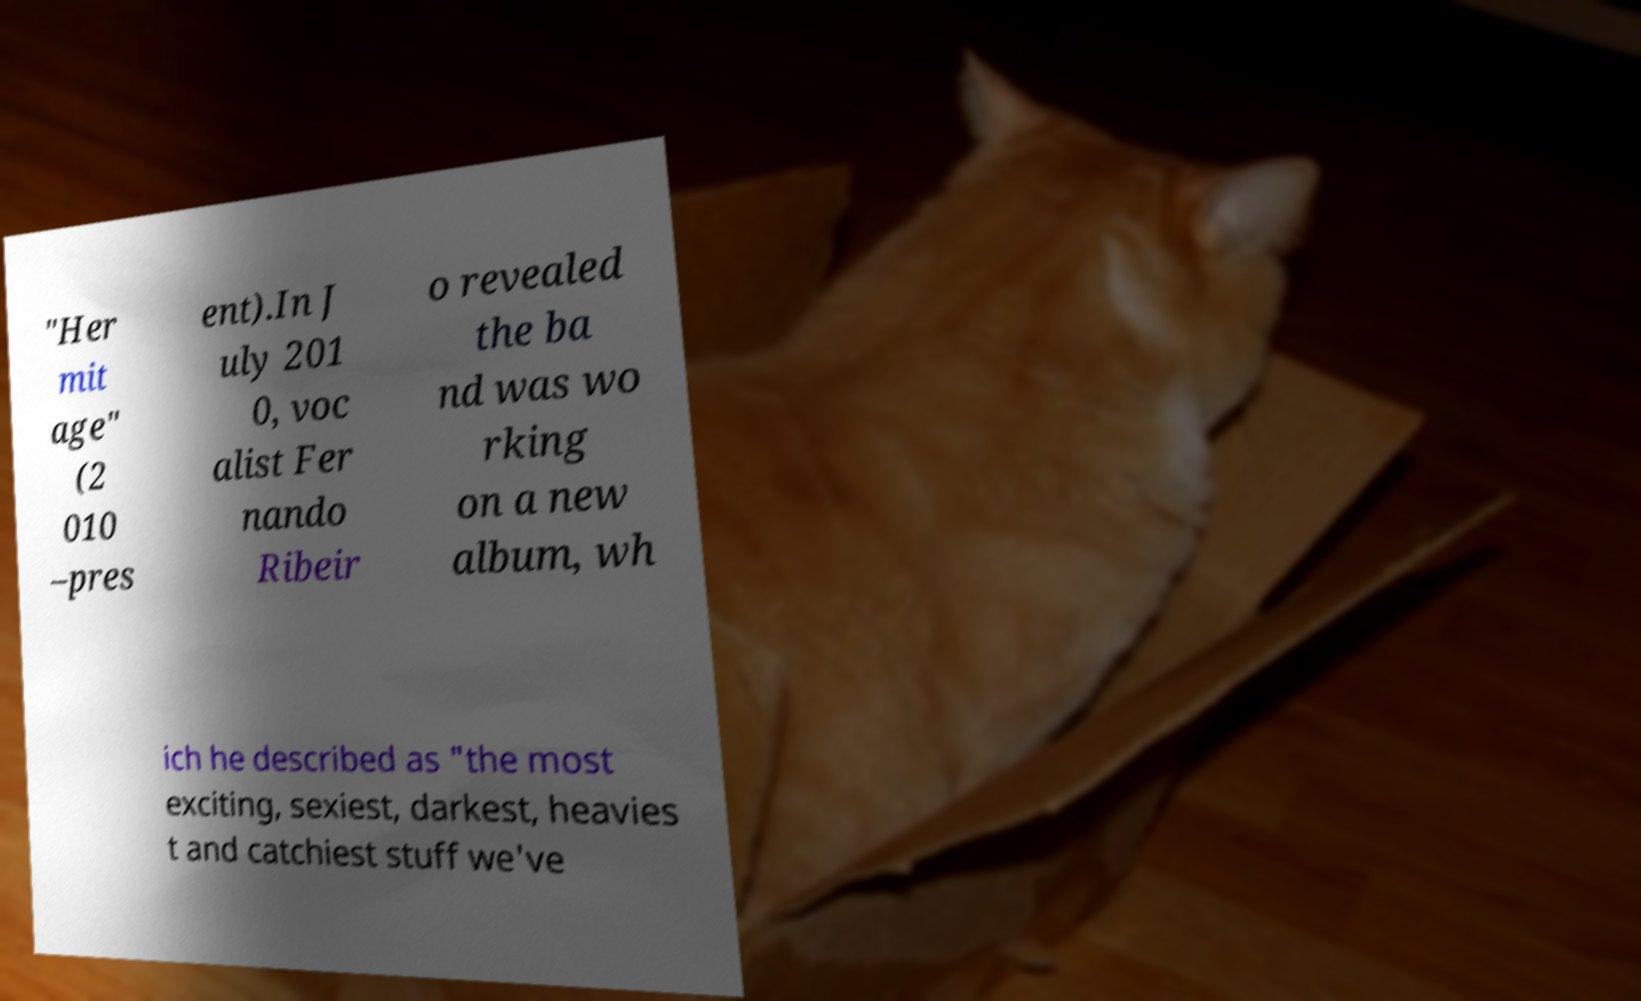Could you assist in decoding the text presented in this image and type it out clearly? "Her mit age" (2 010 –pres ent).In J uly 201 0, voc alist Fer nando Ribeir o revealed the ba nd was wo rking on a new album, wh ich he described as "the most exciting, sexiest, darkest, heavies t and catchiest stuff we've 